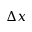<formula> <loc_0><loc_0><loc_500><loc_500>\Delta x</formula> 